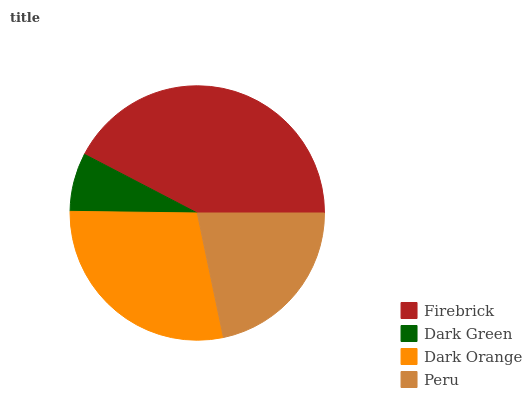Is Dark Green the minimum?
Answer yes or no. Yes. Is Firebrick the maximum?
Answer yes or no. Yes. Is Dark Orange the minimum?
Answer yes or no. No. Is Dark Orange the maximum?
Answer yes or no. No. Is Dark Orange greater than Dark Green?
Answer yes or no. Yes. Is Dark Green less than Dark Orange?
Answer yes or no. Yes. Is Dark Green greater than Dark Orange?
Answer yes or no. No. Is Dark Orange less than Dark Green?
Answer yes or no. No. Is Dark Orange the high median?
Answer yes or no. Yes. Is Peru the low median?
Answer yes or no. Yes. Is Firebrick the high median?
Answer yes or no. No. Is Dark Orange the low median?
Answer yes or no. No. 